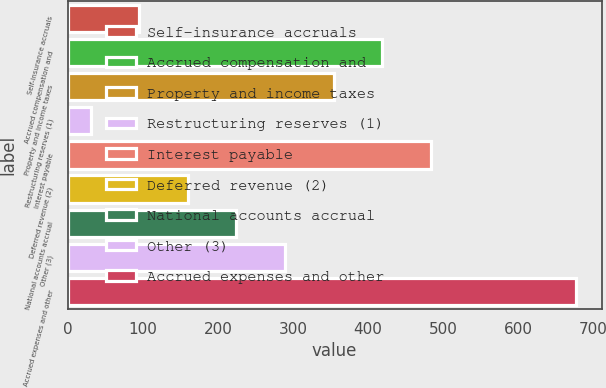Convert chart to OTSL. <chart><loc_0><loc_0><loc_500><loc_500><bar_chart><fcel>Self-insurance accruals<fcel>Accrued compensation and<fcel>Property and income taxes<fcel>Restructuring reserves (1)<fcel>Interest payable<fcel>Deferred revenue (2)<fcel>National accounts accrual<fcel>Other (3)<fcel>Accrued expenses and other<nl><fcel>95.6<fcel>418.6<fcel>354<fcel>31<fcel>483.2<fcel>160.2<fcel>224.8<fcel>289.4<fcel>677<nl></chart> 